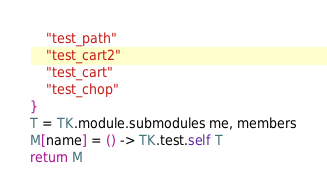<code> <loc_0><loc_0><loc_500><loc_500><_MoonScript_>    "test_path"
    "test_cart2"
    "test_cart"
    "test_chop"
}
T = TK.module.submodules me, members
M[name] = () -> TK.test.self T
return M</code> 